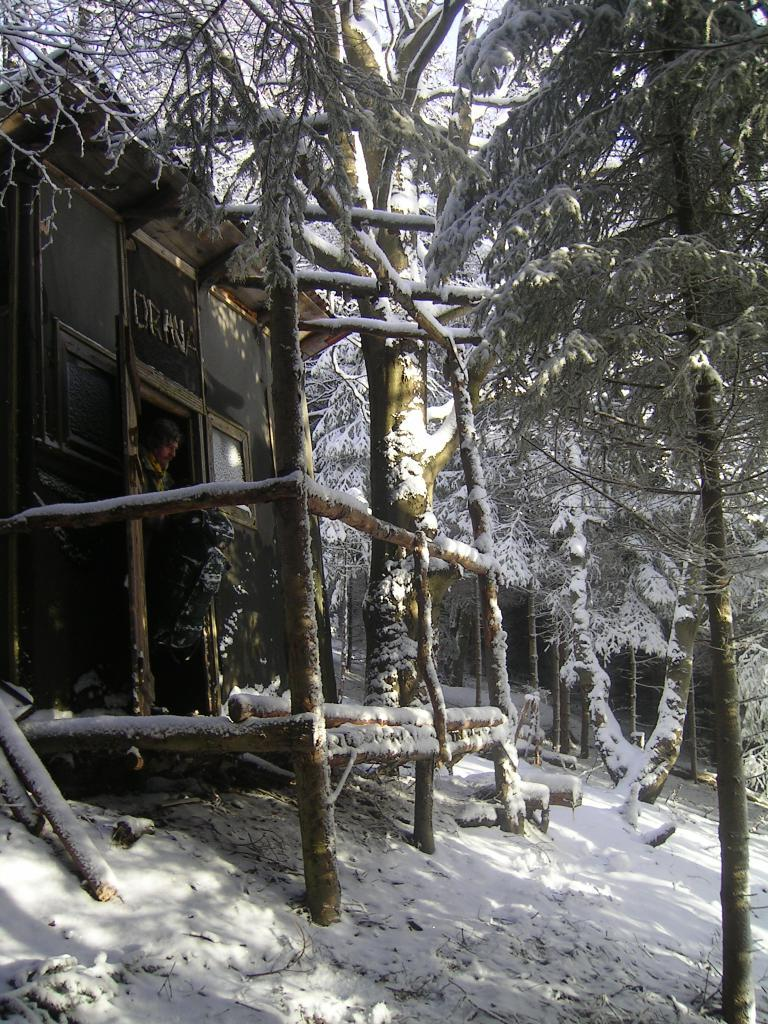What type of structure is visible in the image? There is a building with wooden poles in the image. What is the person in the image holding? The person is holding a bag in the image. Where is the person standing in relation to the building? The person is standing in front of the building. What type of vegetation can be seen in the image? There are trees in the image. What is the overall condition of the scene in the image? The entire scene is covered with snow. Where is the market located in the image? There is no mention of a market in the image; it features a building, a person holding a bag, trees, and snow. What type of ball is being used by the person in the image? There is no ball present in the image; the person is holding a bag. 